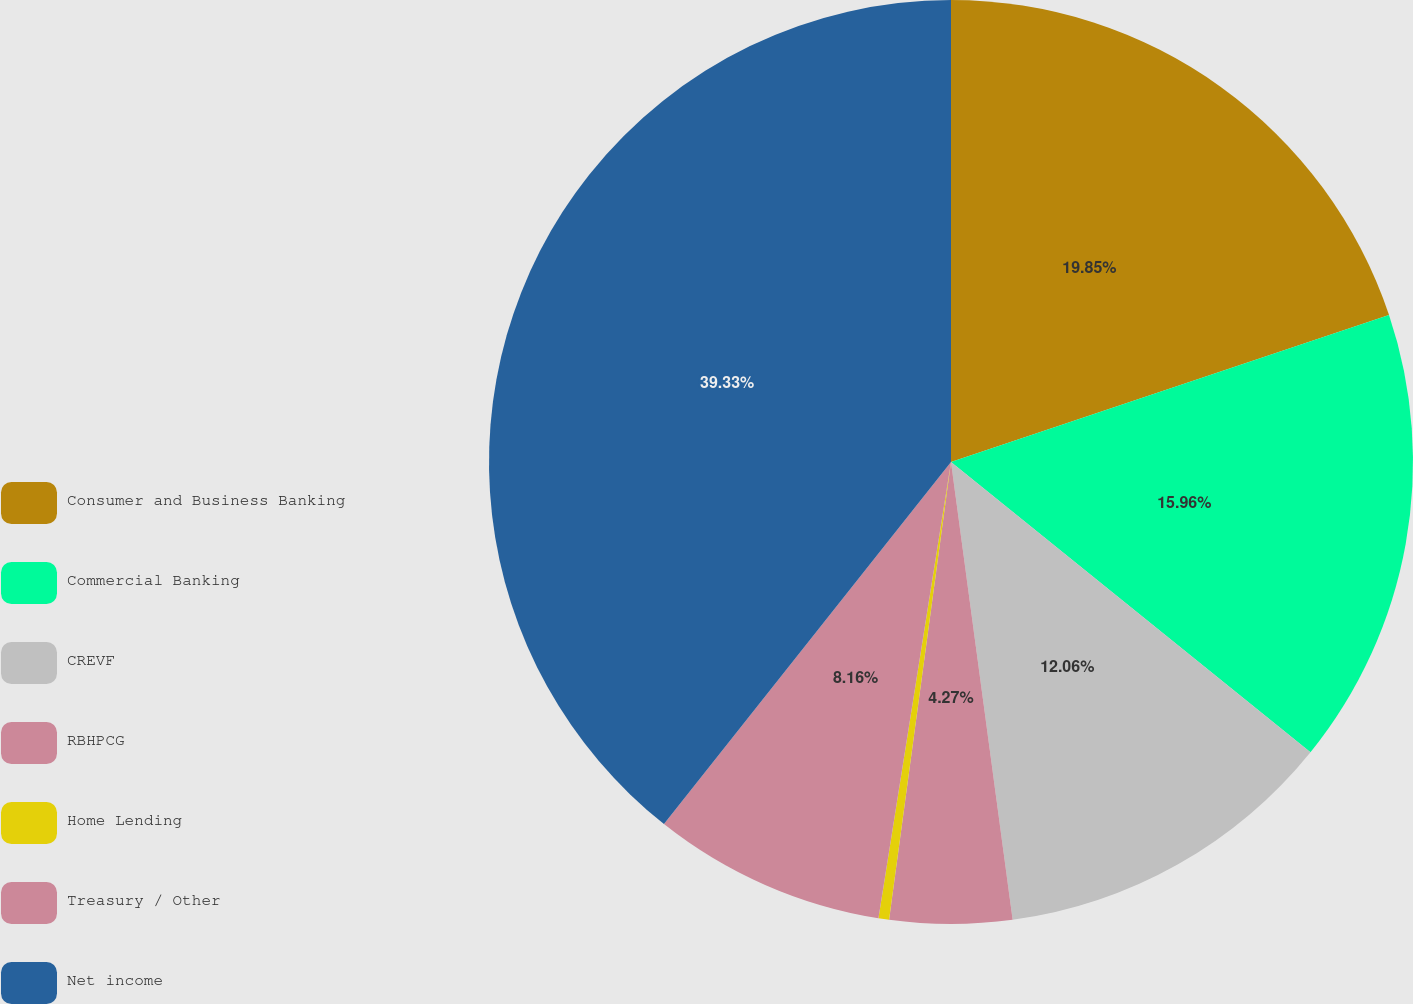Convert chart. <chart><loc_0><loc_0><loc_500><loc_500><pie_chart><fcel>Consumer and Business Banking<fcel>Commercial Banking<fcel>CREVF<fcel>RBHPCG<fcel>Home Lending<fcel>Treasury / Other<fcel>Net income<nl><fcel>19.85%<fcel>15.96%<fcel>12.06%<fcel>4.27%<fcel>0.37%<fcel>8.16%<fcel>39.33%<nl></chart> 